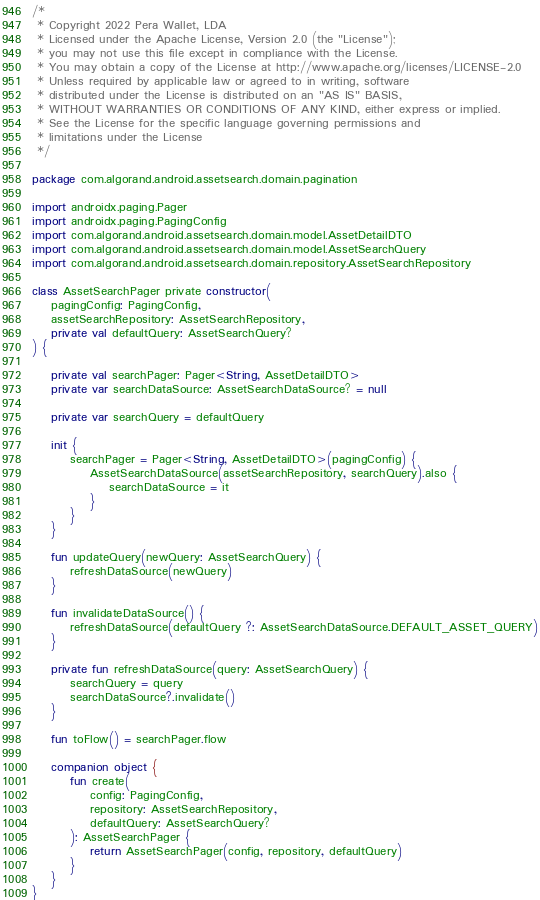Convert code to text. <code><loc_0><loc_0><loc_500><loc_500><_Kotlin_>/*
 * Copyright 2022 Pera Wallet, LDA
 * Licensed under the Apache License, Version 2.0 (the "License");
 * you may not use this file except in compliance with the License.
 * You may obtain a copy of the License at http://www.apache.org/licenses/LICENSE-2.0
 * Unless required by applicable law or agreed to in writing, software
 * distributed under the License is distributed on an "AS IS" BASIS,
 * WITHOUT WARRANTIES OR CONDITIONS OF ANY KIND, either express or implied.
 * See the License for the specific language governing permissions and
 * limitations under the License
 */

package com.algorand.android.assetsearch.domain.pagination

import androidx.paging.Pager
import androidx.paging.PagingConfig
import com.algorand.android.assetsearch.domain.model.AssetDetailDTO
import com.algorand.android.assetsearch.domain.model.AssetSearchQuery
import com.algorand.android.assetsearch.domain.repository.AssetSearchRepository

class AssetSearchPager private constructor(
    pagingConfig: PagingConfig,
    assetSearchRepository: AssetSearchRepository,
    private val defaultQuery: AssetSearchQuery?
) {

    private val searchPager: Pager<String, AssetDetailDTO>
    private var searchDataSource: AssetSearchDataSource? = null

    private var searchQuery = defaultQuery

    init {
        searchPager = Pager<String, AssetDetailDTO>(pagingConfig) {
            AssetSearchDataSource(assetSearchRepository, searchQuery).also {
                searchDataSource = it
            }
        }
    }

    fun updateQuery(newQuery: AssetSearchQuery) {
        refreshDataSource(newQuery)
    }

    fun invalidateDataSource() {
        refreshDataSource(defaultQuery ?: AssetSearchDataSource.DEFAULT_ASSET_QUERY)
    }

    private fun refreshDataSource(query: AssetSearchQuery) {
        searchQuery = query
        searchDataSource?.invalidate()
    }

    fun toFlow() = searchPager.flow

    companion object {
        fun create(
            config: PagingConfig,
            repository: AssetSearchRepository,
            defaultQuery: AssetSearchQuery?
        ): AssetSearchPager {
            return AssetSearchPager(config, repository, defaultQuery)
        }
    }
}
</code> 